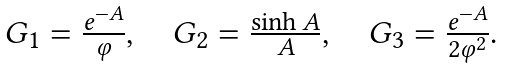<formula> <loc_0><loc_0><loc_500><loc_500>\begin{array} { c } G _ { 1 } = \frac { e ^ { - A } } { \varphi } , \quad G _ { 2 } = \frac { \sinh A } { A } , \quad G _ { 3 } = \frac { e ^ { - A } } { 2 \varphi ^ { 2 } } . \end{array}</formula> 